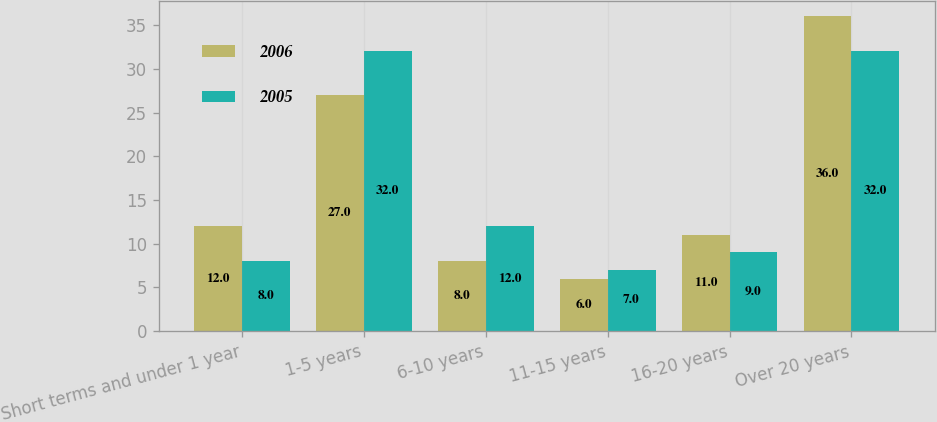Convert chart to OTSL. <chart><loc_0><loc_0><loc_500><loc_500><stacked_bar_chart><ecel><fcel>Short terms and under 1 year<fcel>1-5 years<fcel>6-10 years<fcel>11-15 years<fcel>16-20 years<fcel>Over 20 years<nl><fcel>2006<fcel>12<fcel>27<fcel>8<fcel>6<fcel>11<fcel>36<nl><fcel>2005<fcel>8<fcel>32<fcel>12<fcel>7<fcel>9<fcel>32<nl></chart> 